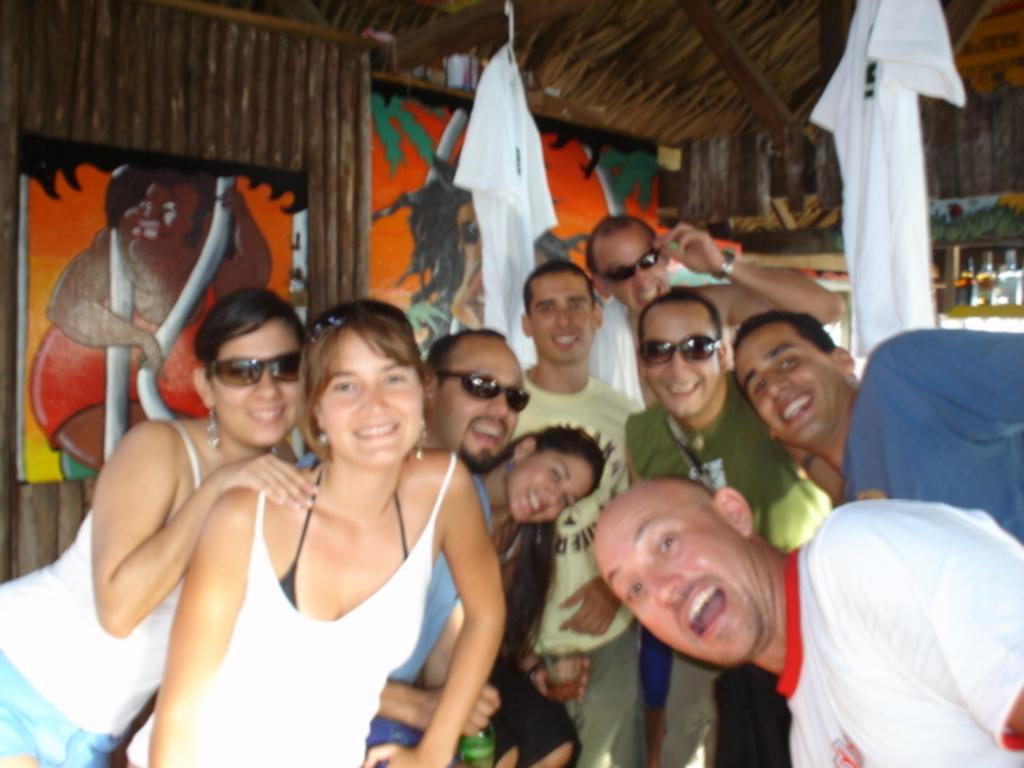Describe this image in one or two sentences. In this image we can see many people. Some are wearing goggles. And we can see dresses hung. In the back we can see bottles. Also there are wooden walls with photo frames. 